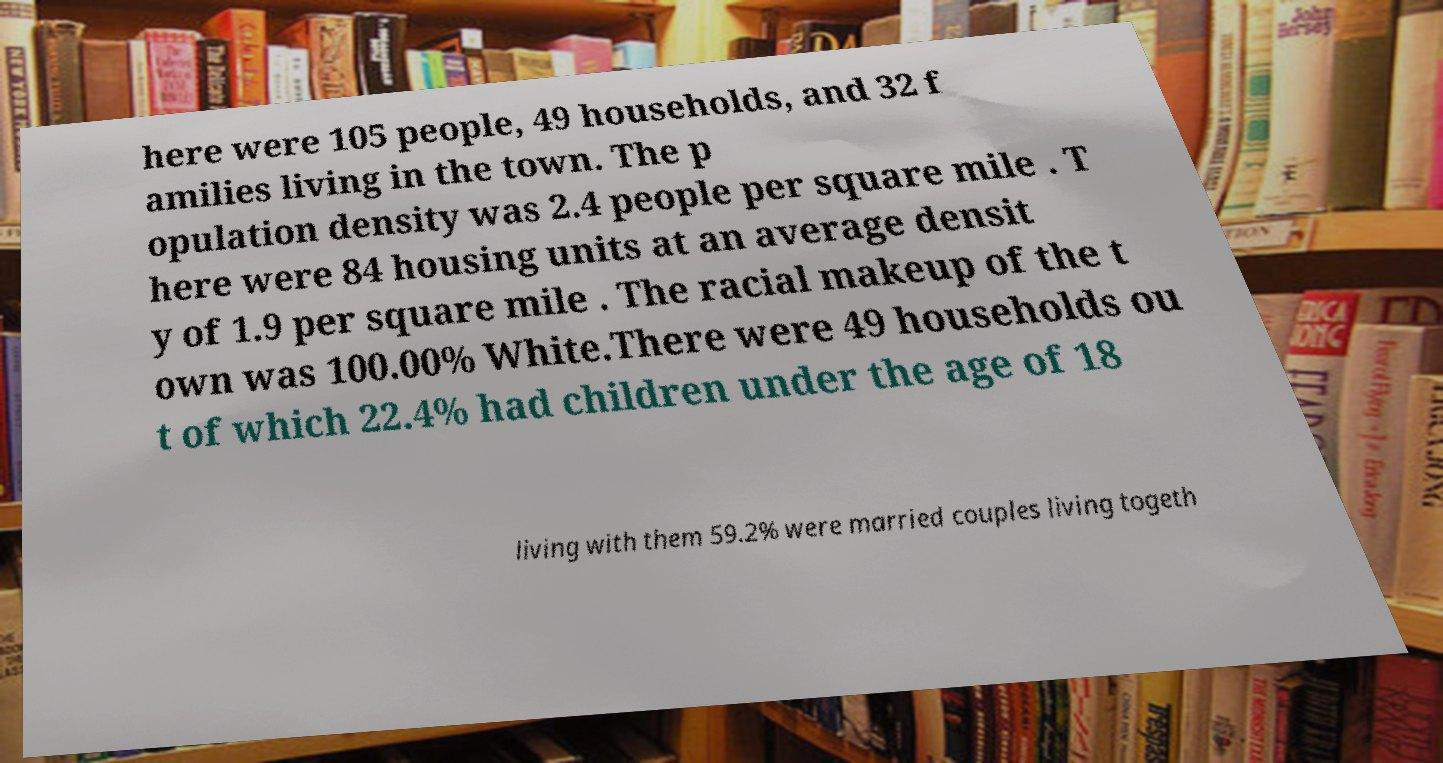Could you assist in decoding the text presented in this image and type it out clearly? here were 105 people, 49 households, and 32 f amilies living in the town. The p opulation density was 2.4 people per square mile . T here were 84 housing units at an average densit y of 1.9 per square mile . The racial makeup of the t own was 100.00% White.There were 49 households ou t of which 22.4% had children under the age of 18 living with them 59.2% were married couples living togeth 